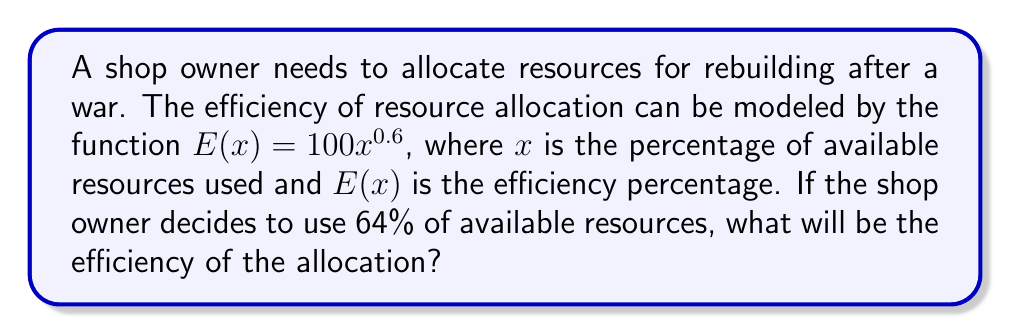What is the answer to this math problem? To solve this problem, we need to follow these steps:

1. Identify the given information:
   - The efficiency function is $E(x) = 100x^{0.6}$
   - The shop owner uses 64% of available resources, so $x = 0.64$

2. Substitute the value of $x$ into the efficiency function:
   $E(0.64) = 100(0.64)^{0.6}$

3. Calculate the result:
   $E(0.64) = 100 \cdot 0.64^{0.6}$
   $= 100 \cdot 0.7712477$
   $= 77.12477$

4. Round the result to two decimal places:
   $E(0.64) \approx 77.12\%$

Therefore, the efficiency of resource allocation when using 64% of available resources is approximately 77.12%.
Answer: 77.12% 